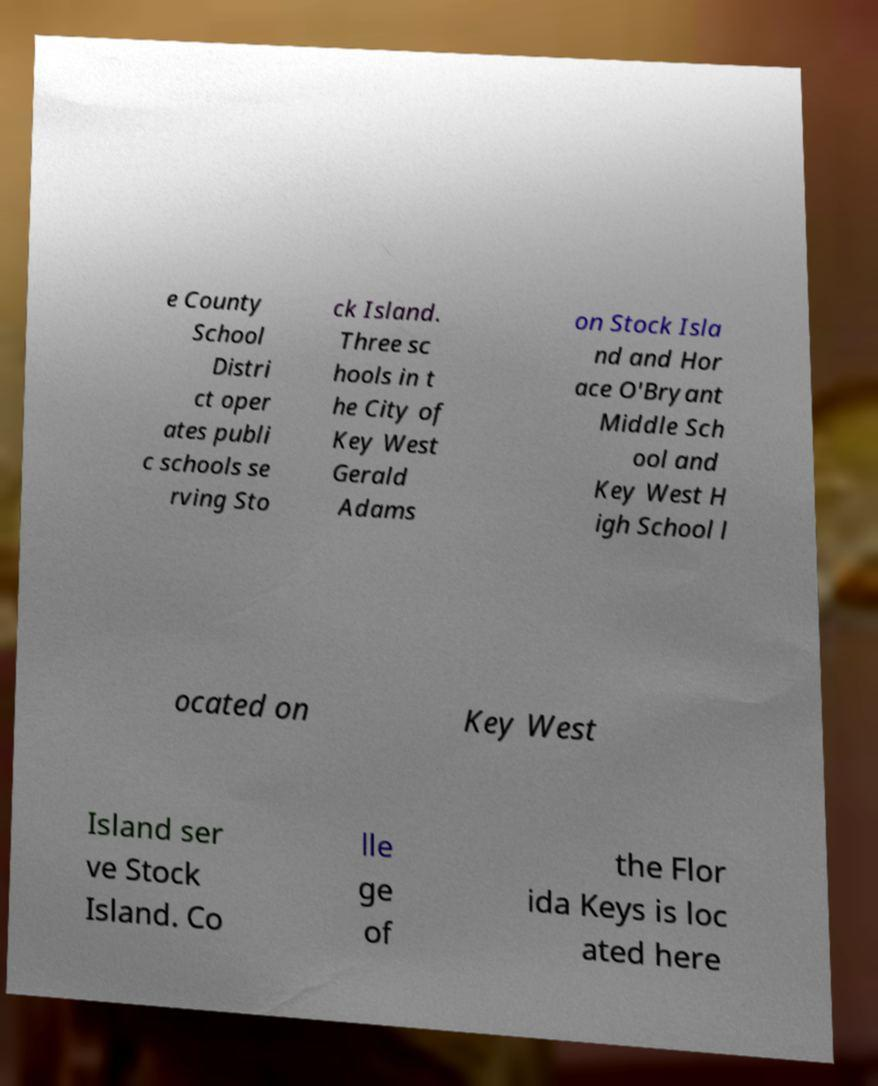Can you read and provide the text displayed in the image?This photo seems to have some interesting text. Can you extract and type it out for me? e County School Distri ct oper ates publi c schools se rving Sto ck Island. Three sc hools in t he City of Key West Gerald Adams on Stock Isla nd and Hor ace O'Bryant Middle Sch ool and Key West H igh School l ocated on Key West Island ser ve Stock Island. Co lle ge of the Flor ida Keys is loc ated here 